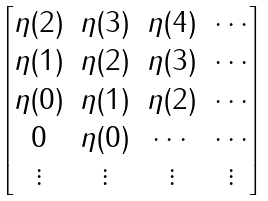<formula> <loc_0><loc_0><loc_500><loc_500>\begin{bmatrix} \eta ( 2 ) & \eta ( 3 ) & \eta ( 4 ) & \cdots \\ \eta ( 1 ) & \eta ( 2 ) & \eta ( 3 ) & \cdots \\ \eta ( 0 ) & \eta ( 1 ) & \eta ( 2 ) & \cdots \\ 0 & \eta ( 0 ) & \cdots & \cdots \\ \vdots & \vdots & \vdots & \vdots \end{bmatrix}</formula> 